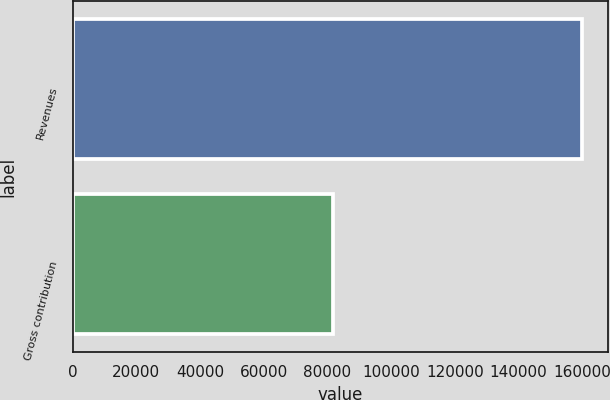Convert chart. <chart><loc_0><loc_0><loc_500><loc_500><bar_chart><fcel>Revenues<fcel>Gross contribution<nl><fcel>160065<fcel>81908<nl></chart> 